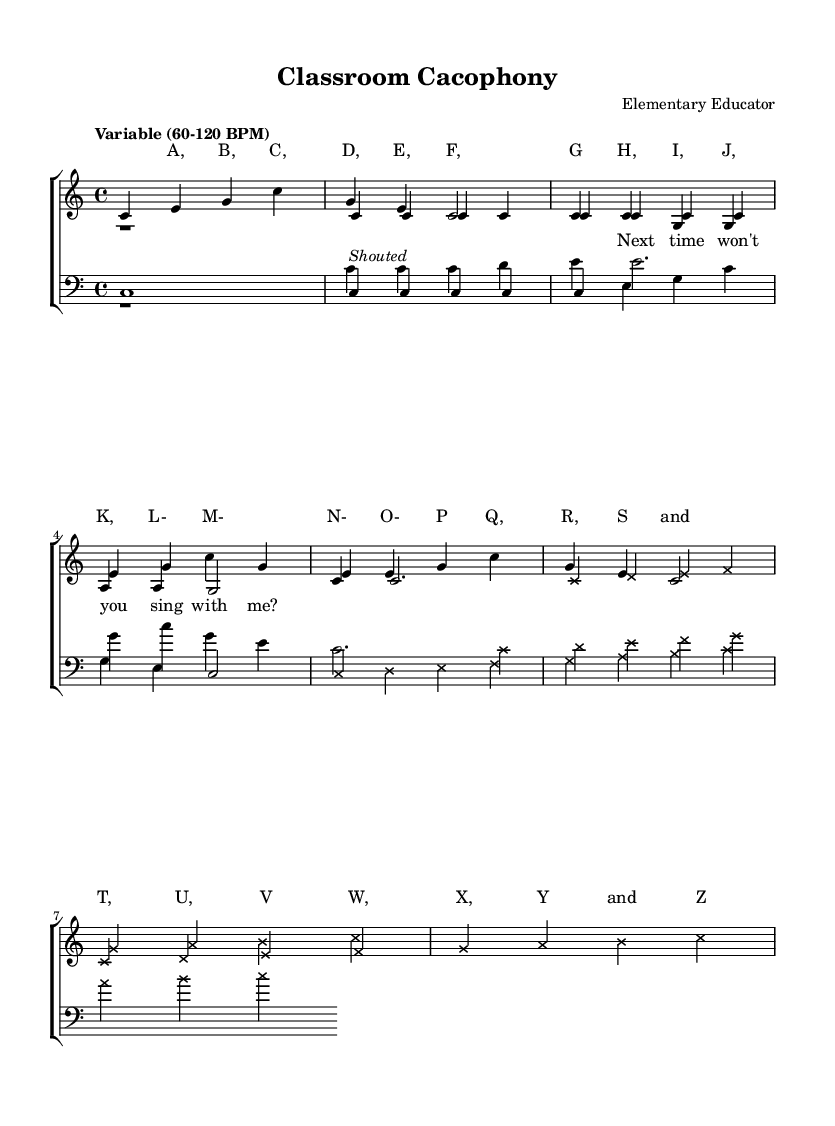What is the key signature of this music? The key signature indicated is C major, which has no sharps or flats, as noted in the global section of the code where " \key c \major" is defined.
Answer: C major What is the time signature of this music? The time signature is 4/4, as denoted by " \time 4/4" in the global section of the code. This means there are four beats per measure.
Answer: 4/4 What is the tempo marking provided in the piece? The tempo marking states "Variable (60-120 BPM)", which suggests that the piece can be played at a tempo ranging from 60 to 120 beats per minute. This is specified in the global section.
Answer: Variable (60-120 BPM) How many voices are present in this composition? This composition features four voices, which can be seen in the "new ChoirStaff" indicating that two staves for voices and one staff for bass voices are present, making a total of four distinct parts.
Answer: Four What is a notable characteristic of the bridge section in this piece? The bridge section displays cross-note heads, indicated by the " \override NoteHead.style = #'cross" syntax in the code, which is a unique visual element used to signify this section different from others.
Answer: Cross-note heads What educational mnemonic is represented in the first verse? The first verse uses the alphabet sequence "A, B, C, D, E, F, G", which is an educational mnemonic familiar to children, helping them remember the order of letters. This is evident in the lyrics section.
Answer: Alphabet letters What vocal technique is indicated in the lyrics of verse one? The lyrics of verse one include the instruction "Shouted" which appears under a note in verse 1, suggesting a vocal technique where the singer should deliver the line with emphasis, almost as if yelling.
Answer: Shouted 